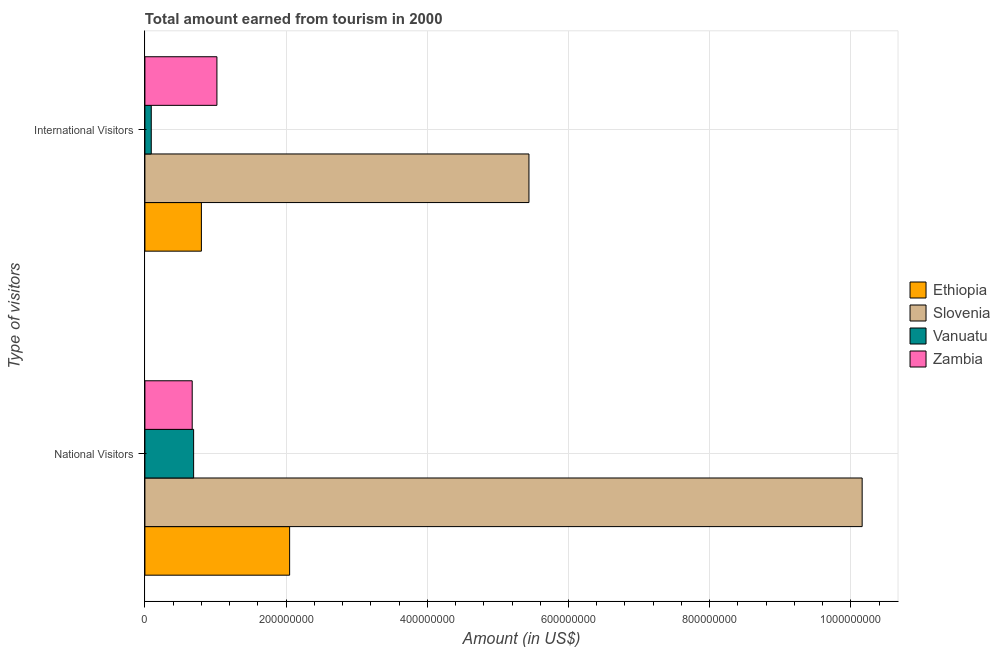How many different coloured bars are there?
Offer a terse response. 4. Are the number of bars per tick equal to the number of legend labels?
Keep it short and to the point. Yes. How many bars are there on the 1st tick from the top?
Make the answer very short. 4. What is the label of the 1st group of bars from the top?
Provide a short and direct response. International Visitors. What is the amount earned from national visitors in Zambia?
Keep it short and to the point. 6.70e+07. Across all countries, what is the maximum amount earned from national visitors?
Offer a very short reply. 1.02e+09. Across all countries, what is the minimum amount earned from national visitors?
Provide a short and direct response. 6.70e+07. In which country was the amount earned from national visitors maximum?
Your answer should be compact. Slovenia. In which country was the amount earned from international visitors minimum?
Ensure brevity in your answer.  Vanuatu. What is the total amount earned from international visitors in the graph?
Ensure brevity in your answer.  7.35e+08. What is the difference between the amount earned from international visitors in Zambia and that in Vanuatu?
Provide a succinct answer. 9.30e+07. What is the difference between the amount earned from national visitors in Vanuatu and the amount earned from international visitors in Slovenia?
Provide a succinct answer. -4.75e+08. What is the average amount earned from national visitors per country?
Provide a succinct answer. 3.39e+08. What is the difference between the amount earned from national visitors and amount earned from international visitors in Vanuatu?
Give a very brief answer. 6.00e+07. In how many countries, is the amount earned from international visitors greater than 440000000 US$?
Offer a very short reply. 1. What is the ratio of the amount earned from national visitors in Zambia to that in Slovenia?
Your answer should be very brief. 0.07. What does the 1st bar from the top in National Visitors represents?
Make the answer very short. Zambia. What does the 3rd bar from the bottom in National Visitors represents?
Ensure brevity in your answer.  Vanuatu. How many bars are there?
Offer a very short reply. 8. Are all the bars in the graph horizontal?
Give a very brief answer. Yes. How many countries are there in the graph?
Make the answer very short. 4. What is the difference between two consecutive major ticks on the X-axis?
Keep it short and to the point. 2.00e+08. Are the values on the major ticks of X-axis written in scientific E-notation?
Provide a short and direct response. No. Does the graph contain any zero values?
Offer a terse response. No. Does the graph contain grids?
Offer a very short reply. Yes. Where does the legend appear in the graph?
Provide a succinct answer. Center right. How many legend labels are there?
Keep it short and to the point. 4. What is the title of the graph?
Keep it short and to the point. Total amount earned from tourism in 2000. Does "St. Kitts and Nevis" appear as one of the legend labels in the graph?
Provide a short and direct response. No. What is the label or title of the X-axis?
Ensure brevity in your answer.  Amount (in US$). What is the label or title of the Y-axis?
Offer a very short reply. Type of visitors. What is the Amount (in US$) in Ethiopia in National Visitors?
Keep it short and to the point. 2.05e+08. What is the Amount (in US$) of Slovenia in National Visitors?
Your answer should be very brief. 1.02e+09. What is the Amount (in US$) in Vanuatu in National Visitors?
Make the answer very short. 6.90e+07. What is the Amount (in US$) of Zambia in National Visitors?
Offer a terse response. 6.70e+07. What is the Amount (in US$) of Ethiopia in International Visitors?
Your response must be concise. 8.00e+07. What is the Amount (in US$) in Slovenia in International Visitors?
Your answer should be compact. 5.44e+08. What is the Amount (in US$) of Vanuatu in International Visitors?
Keep it short and to the point. 9.00e+06. What is the Amount (in US$) of Zambia in International Visitors?
Provide a short and direct response. 1.02e+08. Across all Type of visitors, what is the maximum Amount (in US$) of Ethiopia?
Make the answer very short. 2.05e+08. Across all Type of visitors, what is the maximum Amount (in US$) in Slovenia?
Provide a succinct answer. 1.02e+09. Across all Type of visitors, what is the maximum Amount (in US$) in Vanuatu?
Make the answer very short. 6.90e+07. Across all Type of visitors, what is the maximum Amount (in US$) of Zambia?
Your answer should be compact. 1.02e+08. Across all Type of visitors, what is the minimum Amount (in US$) of Ethiopia?
Your answer should be compact. 8.00e+07. Across all Type of visitors, what is the minimum Amount (in US$) of Slovenia?
Your answer should be very brief. 5.44e+08. Across all Type of visitors, what is the minimum Amount (in US$) of Vanuatu?
Give a very brief answer. 9.00e+06. Across all Type of visitors, what is the minimum Amount (in US$) of Zambia?
Offer a very short reply. 6.70e+07. What is the total Amount (in US$) in Ethiopia in the graph?
Provide a short and direct response. 2.85e+08. What is the total Amount (in US$) in Slovenia in the graph?
Your answer should be compact. 1.56e+09. What is the total Amount (in US$) of Vanuatu in the graph?
Offer a very short reply. 7.80e+07. What is the total Amount (in US$) in Zambia in the graph?
Ensure brevity in your answer.  1.69e+08. What is the difference between the Amount (in US$) of Ethiopia in National Visitors and that in International Visitors?
Give a very brief answer. 1.25e+08. What is the difference between the Amount (in US$) in Slovenia in National Visitors and that in International Visitors?
Keep it short and to the point. 4.72e+08. What is the difference between the Amount (in US$) of Vanuatu in National Visitors and that in International Visitors?
Make the answer very short. 6.00e+07. What is the difference between the Amount (in US$) in Zambia in National Visitors and that in International Visitors?
Your response must be concise. -3.50e+07. What is the difference between the Amount (in US$) of Ethiopia in National Visitors and the Amount (in US$) of Slovenia in International Visitors?
Make the answer very short. -3.39e+08. What is the difference between the Amount (in US$) of Ethiopia in National Visitors and the Amount (in US$) of Vanuatu in International Visitors?
Offer a very short reply. 1.96e+08. What is the difference between the Amount (in US$) in Ethiopia in National Visitors and the Amount (in US$) in Zambia in International Visitors?
Offer a terse response. 1.03e+08. What is the difference between the Amount (in US$) of Slovenia in National Visitors and the Amount (in US$) of Vanuatu in International Visitors?
Offer a very short reply. 1.01e+09. What is the difference between the Amount (in US$) in Slovenia in National Visitors and the Amount (in US$) in Zambia in International Visitors?
Offer a very short reply. 9.14e+08. What is the difference between the Amount (in US$) in Vanuatu in National Visitors and the Amount (in US$) in Zambia in International Visitors?
Your response must be concise. -3.30e+07. What is the average Amount (in US$) of Ethiopia per Type of visitors?
Keep it short and to the point. 1.42e+08. What is the average Amount (in US$) in Slovenia per Type of visitors?
Keep it short and to the point. 7.80e+08. What is the average Amount (in US$) of Vanuatu per Type of visitors?
Your answer should be compact. 3.90e+07. What is the average Amount (in US$) in Zambia per Type of visitors?
Your response must be concise. 8.45e+07. What is the difference between the Amount (in US$) in Ethiopia and Amount (in US$) in Slovenia in National Visitors?
Offer a very short reply. -8.11e+08. What is the difference between the Amount (in US$) in Ethiopia and Amount (in US$) in Vanuatu in National Visitors?
Your answer should be very brief. 1.36e+08. What is the difference between the Amount (in US$) in Ethiopia and Amount (in US$) in Zambia in National Visitors?
Ensure brevity in your answer.  1.38e+08. What is the difference between the Amount (in US$) of Slovenia and Amount (in US$) of Vanuatu in National Visitors?
Your answer should be compact. 9.47e+08. What is the difference between the Amount (in US$) of Slovenia and Amount (in US$) of Zambia in National Visitors?
Offer a terse response. 9.49e+08. What is the difference between the Amount (in US$) in Vanuatu and Amount (in US$) in Zambia in National Visitors?
Make the answer very short. 2.00e+06. What is the difference between the Amount (in US$) of Ethiopia and Amount (in US$) of Slovenia in International Visitors?
Give a very brief answer. -4.64e+08. What is the difference between the Amount (in US$) in Ethiopia and Amount (in US$) in Vanuatu in International Visitors?
Your answer should be very brief. 7.10e+07. What is the difference between the Amount (in US$) of Ethiopia and Amount (in US$) of Zambia in International Visitors?
Provide a short and direct response. -2.20e+07. What is the difference between the Amount (in US$) of Slovenia and Amount (in US$) of Vanuatu in International Visitors?
Keep it short and to the point. 5.35e+08. What is the difference between the Amount (in US$) in Slovenia and Amount (in US$) in Zambia in International Visitors?
Keep it short and to the point. 4.42e+08. What is the difference between the Amount (in US$) of Vanuatu and Amount (in US$) of Zambia in International Visitors?
Give a very brief answer. -9.30e+07. What is the ratio of the Amount (in US$) in Ethiopia in National Visitors to that in International Visitors?
Provide a short and direct response. 2.56. What is the ratio of the Amount (in US$) in Slovenia in National Visitors to that in International Visitors?
Your answer should be very brief. 1.87. What is the ratio of the Amount (in US$) of Vanuatu in National Visitors to that in International Visitors?
Your answer should be compact. 7.67. What is the ratio of the Amount (in US$) in Zambia in National Visitors to that in International Visitors?
Offer a very short reply. 0.66. What is the difference between the highest and the second highest Amount (in US$) of Ethiopia?
Provide a short and direct response. 1.25e+08. What is the difference between the highest and the second highest Amount (in US$) in Slovenia?
Your answer should be very brief. 4.72e+08. What is the difference between the highest and the second highest Amount (in US$) in Vanuatu?
Your answer should be very brief. 6.00e+07. What is the difference between the highest and the second highest Amount (in US$) of Zambia?
Your answer should be very brief. 3.50e+07. What is the difference between the highest and the lowest Amount (in US$) of Ethiopia?
Provide a short and direct response. 1.25e+08. What is the difference between the highest and the lowest Amount (in US$) of Slovenia?
Your answer should be compact. 4.72e+08. What is the difference between the highest and the lowest Amount (in US$) of Vanuatu?
Provide a succinct answer. 6.00e+07. What is the difference between the highest and the lowest Amount (in US$) of Zambia?
Your answer should be very brief. 3.50e+07. 